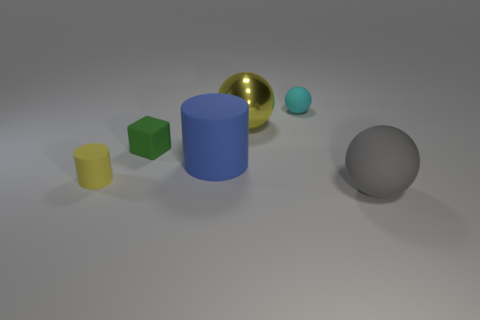Add 3 large matte balls. How many objects exist? 9 Subtract all blocks. How many objects are left? 5 Subtract all tiny yellow matte objects. Subtract all yellow matte cylinders. How many objects are left? 4 Add 6 tiny green blocks. How many tiny green blocks are left? 7 Add 1 cyan things. How many cyan things exist? 2 Subtract 0 purple cubes. How many objects are left? 6 